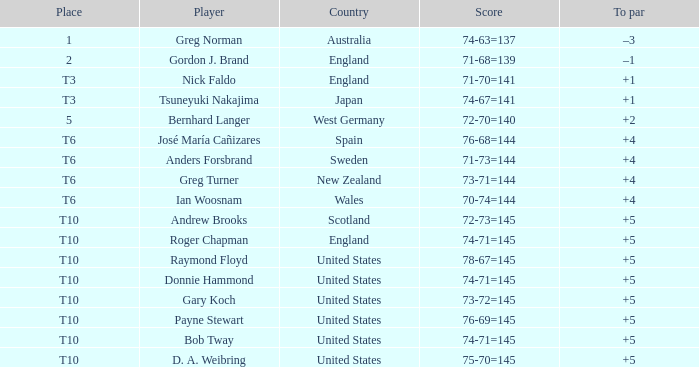What did United States place when the player was Raymond Floyd? T10. 